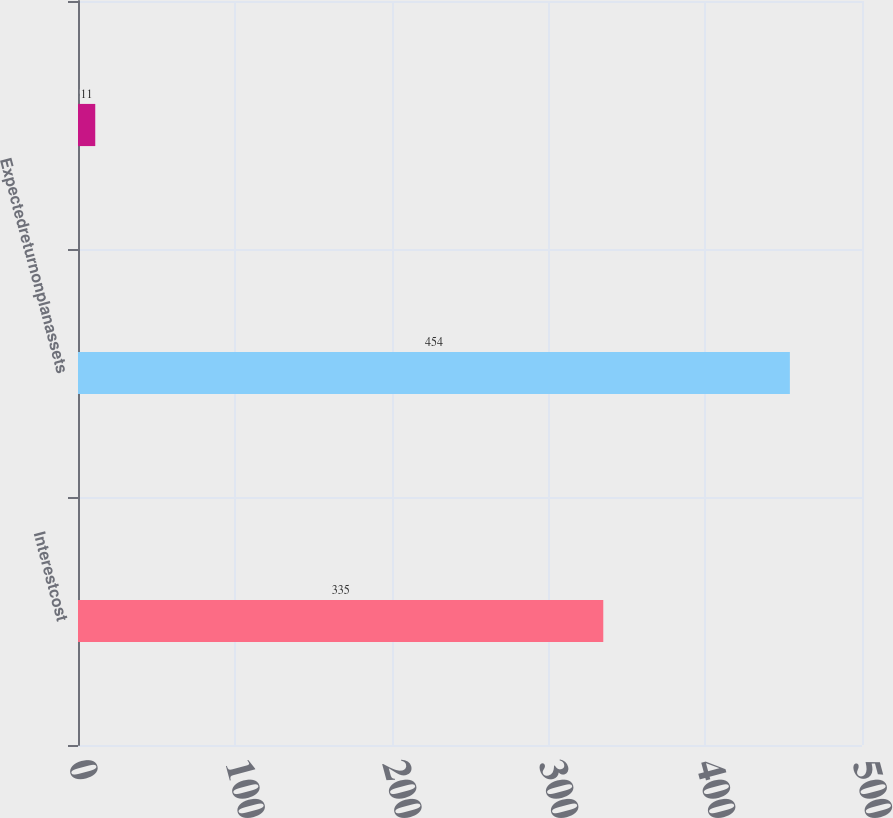Convert chart. <chart><loc_0><loc_0><loc_500><loc_500><bar_chart><fcel>Interestcost<fcel>Expectedreturnonplanassets<fcel>Unnamed: 2<nl><fcel>335<fcel>454<fcel>11<nl></chart> 